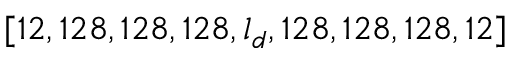<formula> <loc_0><loc_0><loc_500><loc_500>[ 1 2 , 1 2 8 , 1 2 8 , 1 2 8 , l _ { d } , 1 2 8 , 1 2 8 , 1 2 8 , 1 2 ]</formula> 